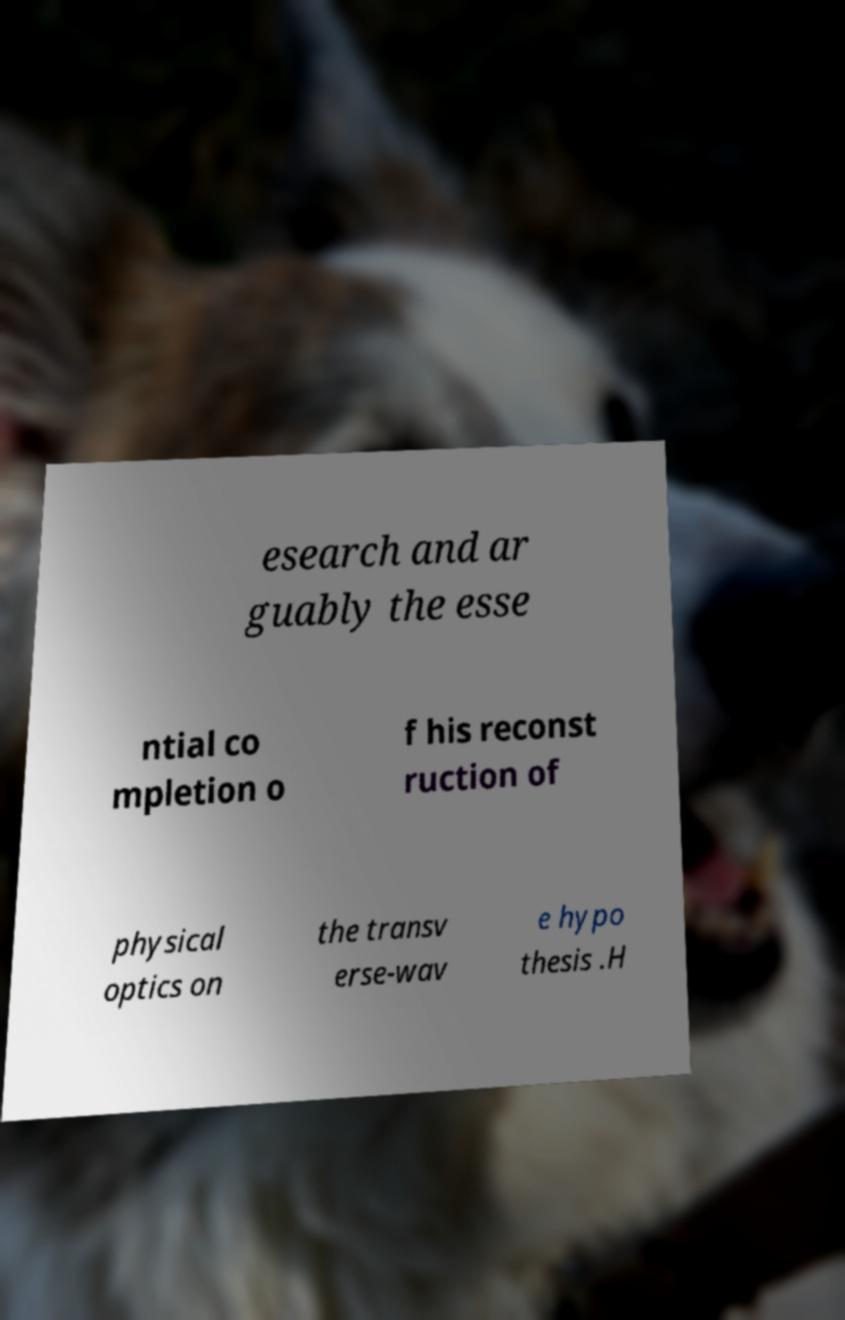There's text embedded in this image that I need extracted. Can you transcribe it verbatim? esearch and ar guably the esse ntial co mpletion o f his reconst ruction of physical optics on the transv erse-wav e hypo thesis .H 